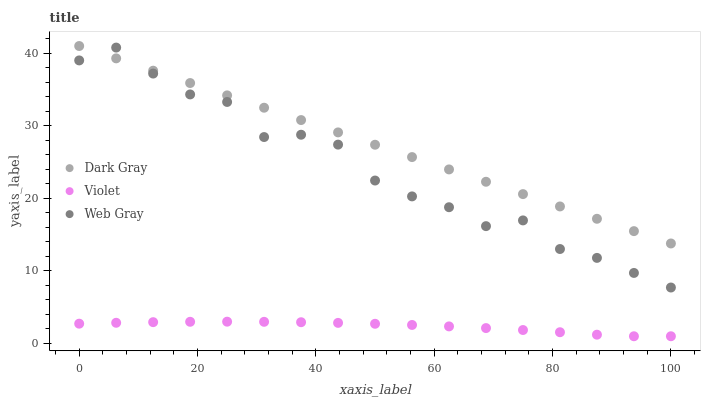Does Violet have the minimum area under the curve?
Answer yes or no. Yes. Does Dark Gray have the maximum area under the curve?
Answer yes or no. Yes. Does Web Gray have the minimum area under the curve?
Answer yes or no. No. Does Web Gray have the maximum area under the curve?
Answer yes or no. No. Is Dark Gray the smoothest?
Answer yes or no. Yes. Is Web Gray the roughest?
Answer yes or no. Yes. Is Violet the smoothest?
Answer yes or no. No. Is Violet the roughest?
Answer yes or no. No. Does Violet have the lowest value?
Answer yes or no. Yes. Does Web Gray have the lowest value?
Answer yes or no. No. Does Dark Gray have the highest value?
Answer yes or no. Yes. Does Web Gray have the highest value?
Answer yes or no. No. Is Violet less than Dark Gray?
Answer yes or no. Yes. Is Dark Gray greater than Violet?
Answer yes or no. Yes. Does Web Gray intersect Dark Gray?
Answer yes or no. Yes. Is Web Gray less than Dark Gray?
Answer yes or no. No. Is Web Gray greater than Dark Gray?
Answer yes or no. No. Does Violet intersect Dark Gray?
Answer yes or no. No. 